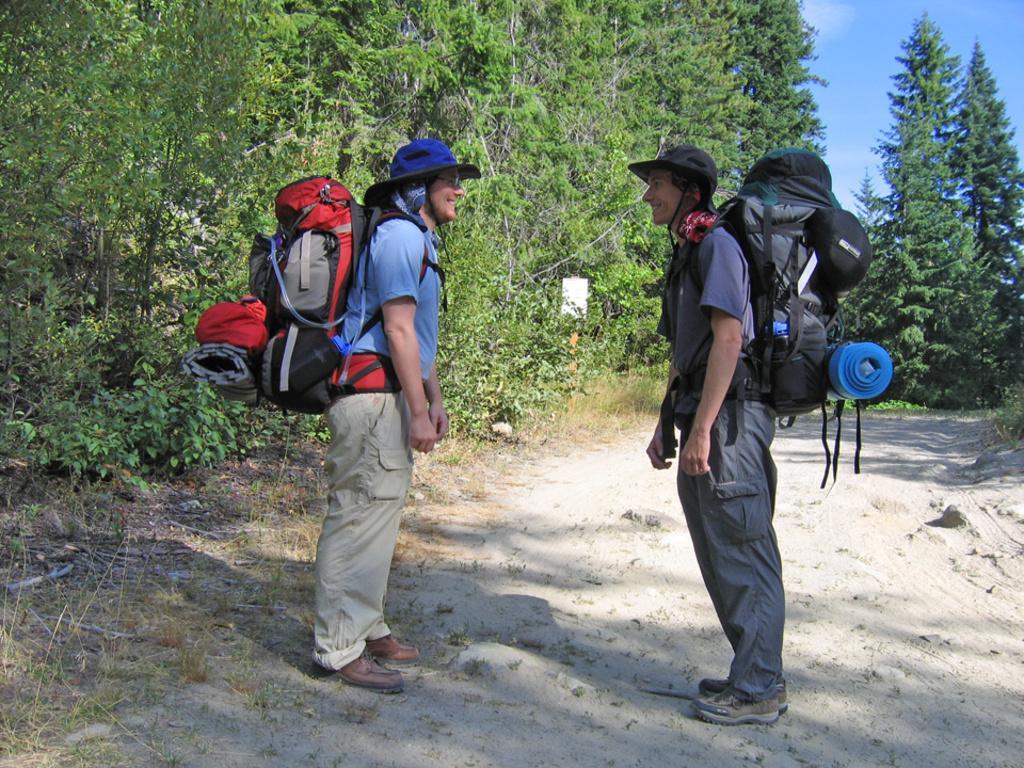Can you describe this image briefly? Here we can see two people wearing hat and travel bags staring towards each other and laughing, beside them we can see trees 